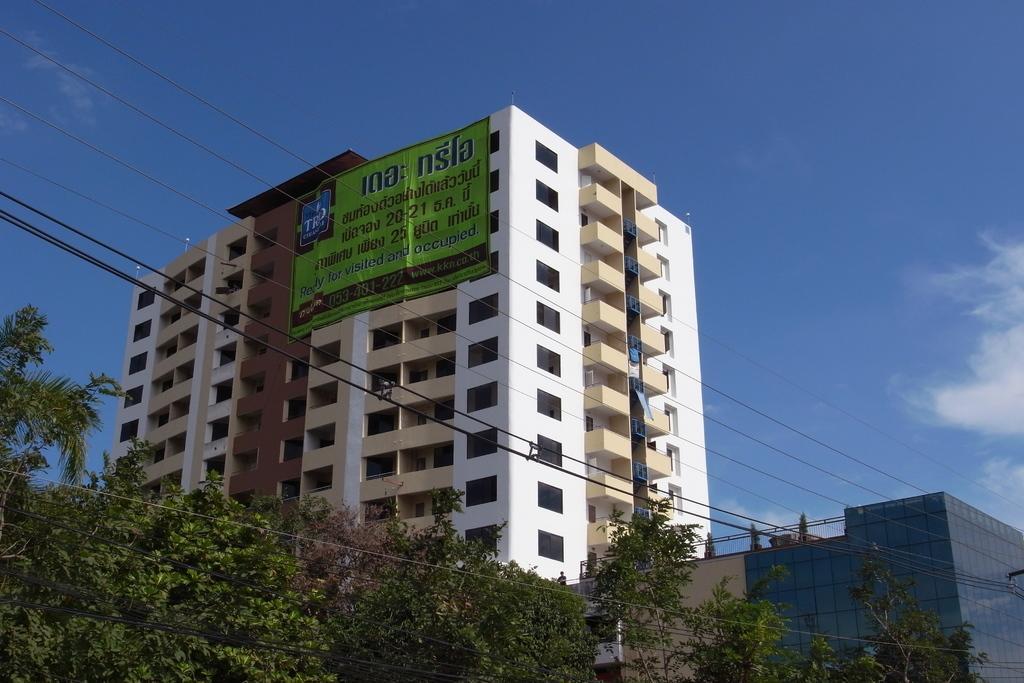Describe this image in one or two sentences. In the image there is a tall building and there is is a huge banner kept in front of the building, there are many trees in the front and in front of those trees there are a lot of wires. 